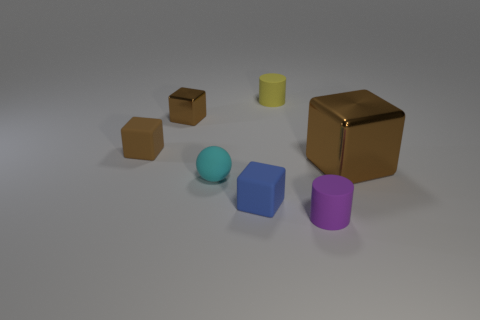How many brown blocks must be subtracted to get 2 brown blocks? 1 Subtract all green cylinders. How many brown cubes are left? 3 Add 3 small blue blocks. How many objects exist? 10 Subtract all blocks. How many objects are left? 3 Add 6 tiny blue matte objects. How many tiny blue matte objects exist? 7 Subtract 0 gray cylinders. How many objects are left? 7 Subtract all large purple matte objects. Subtract all small yellow objects. How many objects are left? 6 Add 3 tiny cyan matte spheres. How many tiny cyan matte spheres are left? 4 